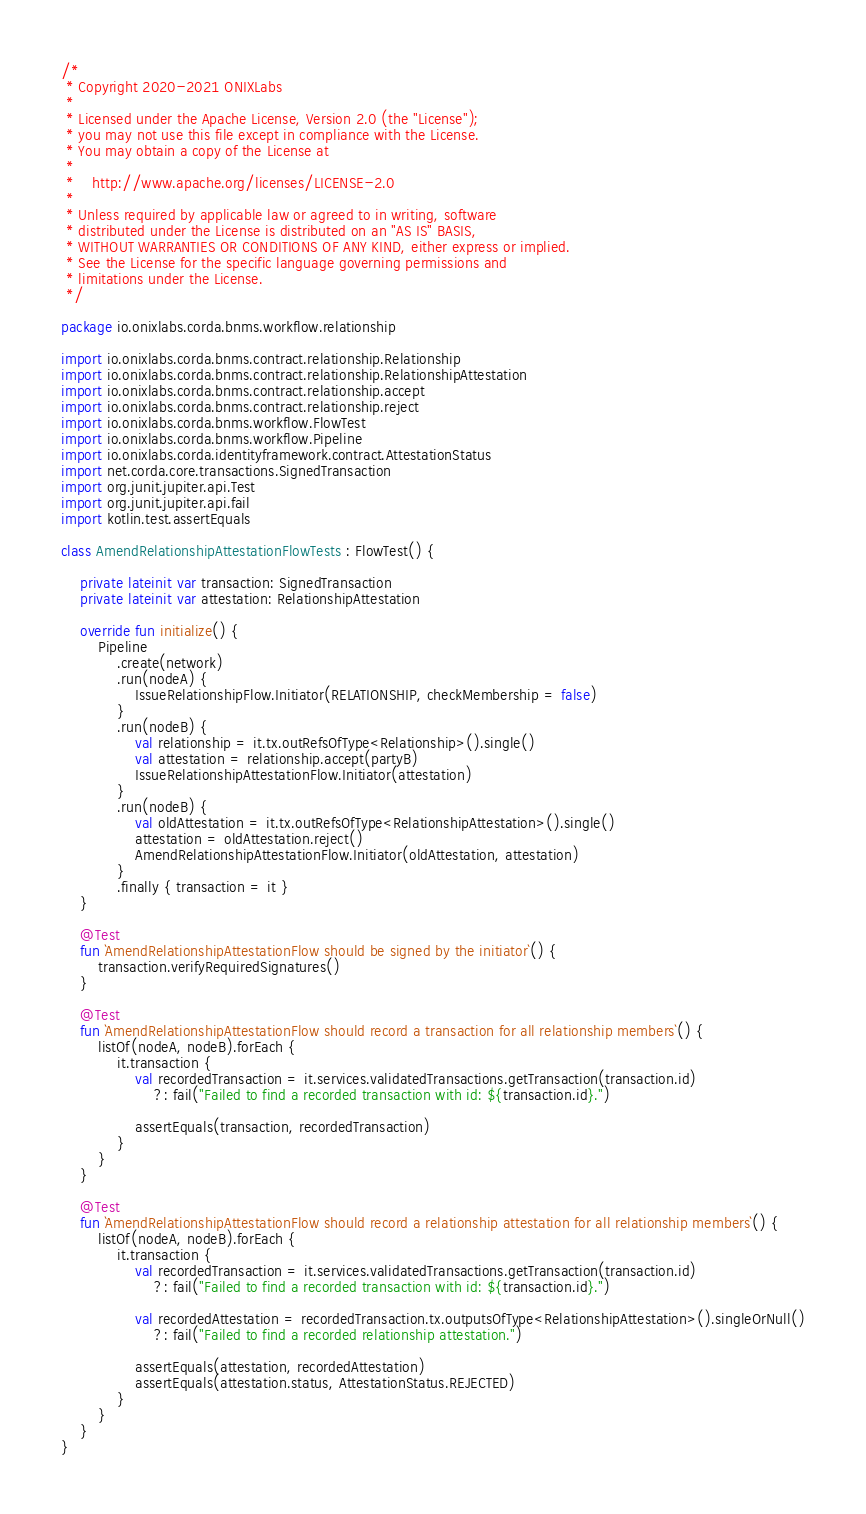Convert code to text. <code><loc_0><loc_0><loc_500><loc_500><_Kotlin_>/*
 * Copyright 2020-2021 ONIXLabs
 *
 * Licensed under the Apache License, Version 2.0 (the "License");
 * you may not use this file except in compliance with the License.
 * You may obtain a copy of the License at
 *
 *    http://www.apache.org/licenses/LICENSE-2.0
 *
 * Unless required by applicable law or agreed to in writing, software
 * distributed under the License is distributed on an "AS IS" BASIS,
 * WITHOUT WARRANTIES OR CONDITIONS OF ANY KIND, either express or implied.
 * See the License for the specific language governing permissions and
 * limitations under the License.
 */

package io.onixlabs.corda.bnms.workflow.relationship

import io.onixlabs.corda.bnms.contract.relationship.Relationship
import io.onixlabs.corda.bnms.contract.relationship.RelationshipAttestation
import io.onixlabs.corda.bnms.contract.relationship.accept
import io.onixlabs.corda.bnms.contract.relationship.reject
import io.onixlabs.corda.bnms.workflow.FlowTest
import io.onixlabs.corda.bnms.workflow.Pipeline
import io.onixlabs.corda.identityframework.contract.AttestationStatus
import net.corda.core.transactions.SignedTransaction
import org.junit.jupiter.api.Test
import org.junit.jupiter.api.fail
import kotlin.test.assertEquals

class AmendRelationshipAttestationFlowTests : FlowTest() {

    private lateinit var transaction: SignedTransaction
    private lateinit var attestation: RelationshipAttestation

    override fun initialize() {
        Pipeline
            .create(network)
            .run(nodeA) {
                IssueRelationshipFlow.Initiator(RELATIONSHIP, checkMembership = false)
            }
            .run(nodeB) {
                val relationship = it.tx.outRefsOfType<Relationship>().single()
                val attestation = relationship.accept(partyB)
                IssueRelationshipAttestationFlow.Initiator(attestation)
            }
            .run(nodeB) {
                val oldAttestation = it.tx.outRefsOfType<RelationshipAttestation>().single()
                attestation = oldAttestation.reject()
                AmendRelationshipAttestationFlow.Initiator(oldAttestation, attestation)
            }
            .finally { transaction = it }
    }

    @Test
    fun `AmendRelationshipAttestationFlow should be signed by the initiator`() {
        transaction.verifyRequiredSignatures()
    }

    @Test
    fun `AmendRelationshipAttestationFlow should record a transaction for all relationship members`() {
        listOf(nodeA, nodeB).forEach {
            it.transaction {
                val recordedTransaction = it.services.validatedTransactions.getTransaction(transaction.id)
                    ?: fail("Failed to find a recorded transaction with id: ${transaction.id}.")

                assertEquals(transaction, recordedTransaction)
            }
        }
    }

    @Test
    fun `AmendRelationshipAttestationFlow should record a relationship attestation for all relationship members`() {
        listOf(nodeA, nodeB).forEach {
            it.transaction {
                val recordedTransaction = it.services.validatedTransactions.getTransaction(transaction.id)
                    ?: fail("Failed to find a recorded transaction with id: ${transaction.id}.")

                val recordedAttestation = recordedTransaction.tx.outputsOfType<RelationshipAttestation>().singleOrNull()
                    ?: fail("Failed to find a recorded relationship attestation.")

                assertEquals(attestation, recordedAttestation)
                assertEquals(attestation.status, AttestationStatus.REJECTED)
            }
        }
    }
}
</code> 